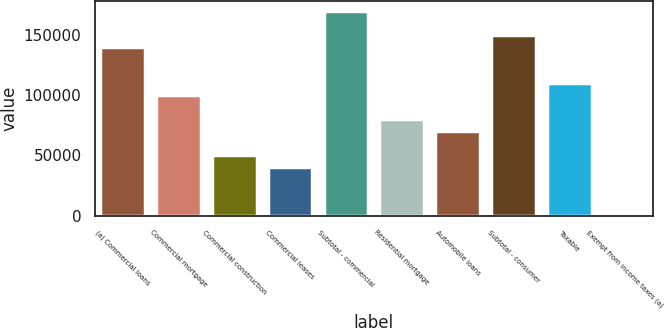<chart> <loc_0><loc_0><loc_500><loc_500><bar_chart><fcel>(a) Commercial loans<fcel>Commercial mortgage<fcel>Commercial construction<fcel>Commercial leases<fcel>Subtotal - commercial<fcel>Residential mortgage<fcel>Automobile loans<fcel>Subtotal - consumer<fcel>Taxable<fcel>Exempt from income taxes (a)<nl><fcel>139695<fcel>99880<fcel>50111<fcel>40157.2<fcel>169557<fcel>79972.4<fcel>70018.6<fcel>149649<fcel>109834<fcel>342<nl></chart> 